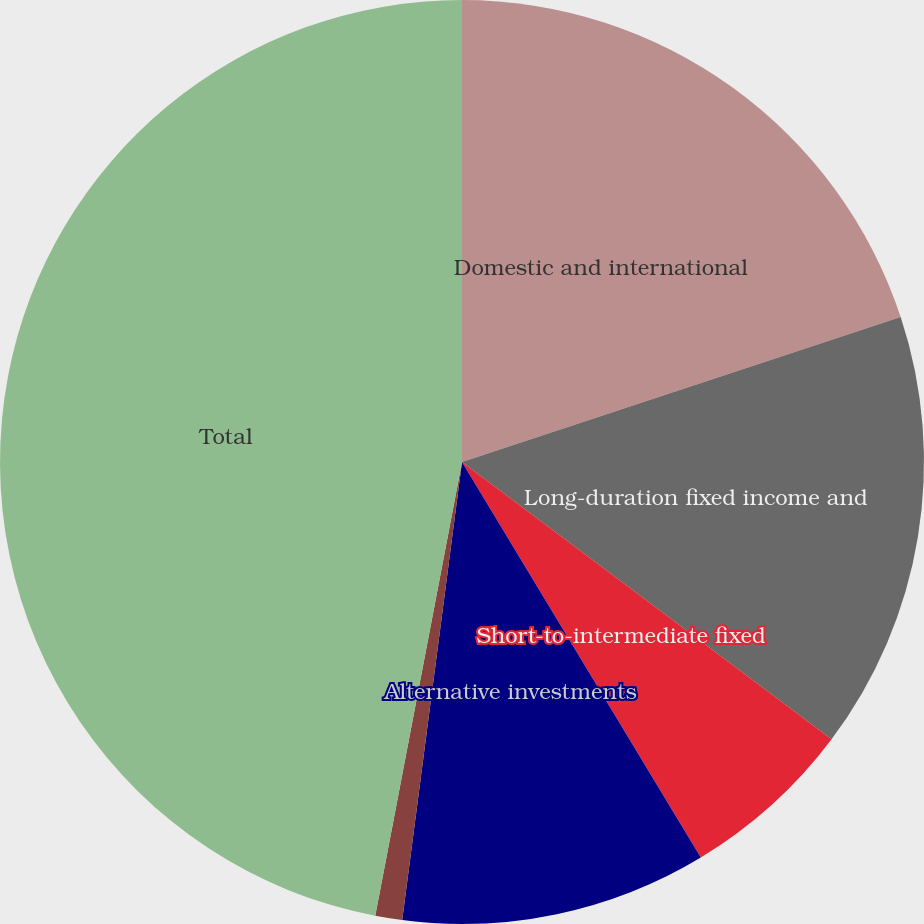<chart> <loc_0><loc_0><loc_500><loc_500><pie_chart><fcel>Domestic and international<fcel>Long-duration fixed income and<fcel>Short-to-intermediate fixed<fcel>Alternative investments<fcel>Cash<fcel>Total<nl><fcel>19.92%<fcel>15.32%<fcel>6.11%<fcel>10.71%<fcel>0.94%<fcel>46.99%<nl></chart> 